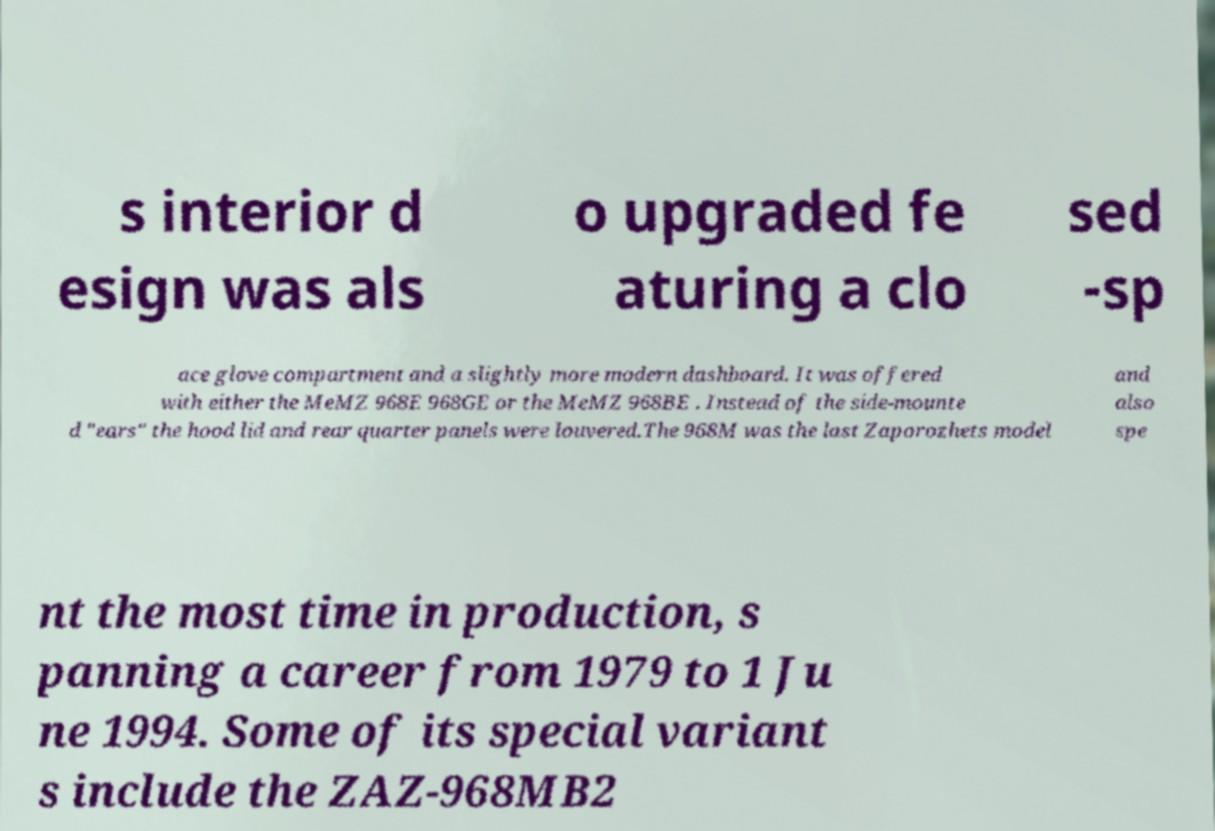I need the written content from this picture converted into text. Can you do that? s interior d esign was als o upgraded fe aturing a clo sed -sp ace glove compartment and a slightly more modern dashboard. It was offered with either the MeMZ 968E 968GE or the MeMZ 968BE . Instead of the side-mounte d "ears" the hood lid and rear quarter panels were louvered.The 968M was the last Zaporozhets model and also spe nt the most time in production, s panning a career from 1979 to 1 Ju ne 1994. Some of its special variant s include the ZAZ-968MB2 